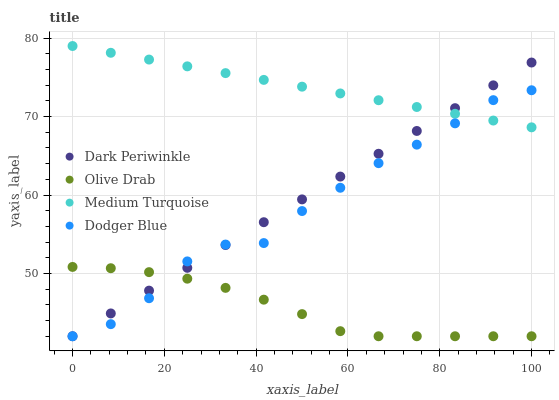Does Olive Drab have the minimum area under the curve?
Answer yes or no. Yes. Does Medium Turquoise have the maximum area under the curve?
Answer yes or no. Yes. Does Dodger Blue have the minimum area under the curve?
Answer yes or no. No. Does Dodger Blue have the maximum area under the curve?
Answer yes or no. No. Is Medium Turquoise the smoothest?
Answer yes or no. Yes. Is Dodger Blue the roughest?
Answer yes or no. Yes. Is Dark Periwinkle the smoothest?
Answer yes or no. No. Is Dark Periwinkle the roughest?
Answer yes or no. No. Does Dodger Blue have the lowest value?
Answer yes or no. Yes. Does Medium Turquoise have the highest value?
Answer yes or no. Yes. Does Dodger Blue have the highest value?
Answer yes or no. No. Is Olive Drab less than Medium Turquoise?
Answer yes or no. Yes. Is Medium Turquoise greater than Olive Drab?
Answer yes or no. Yes. Does Olive Drab intersect Dodger Blue?
Answer yes or no. Yes. Is Olive Drab less than Dodger Blue?
Answer yes or no. No. Is Olive Drab greater than Dodger Blue?
Answer yes or no. No. Does Olive Drab intersect Medium Turquoise?
Answer yes or no. No. 